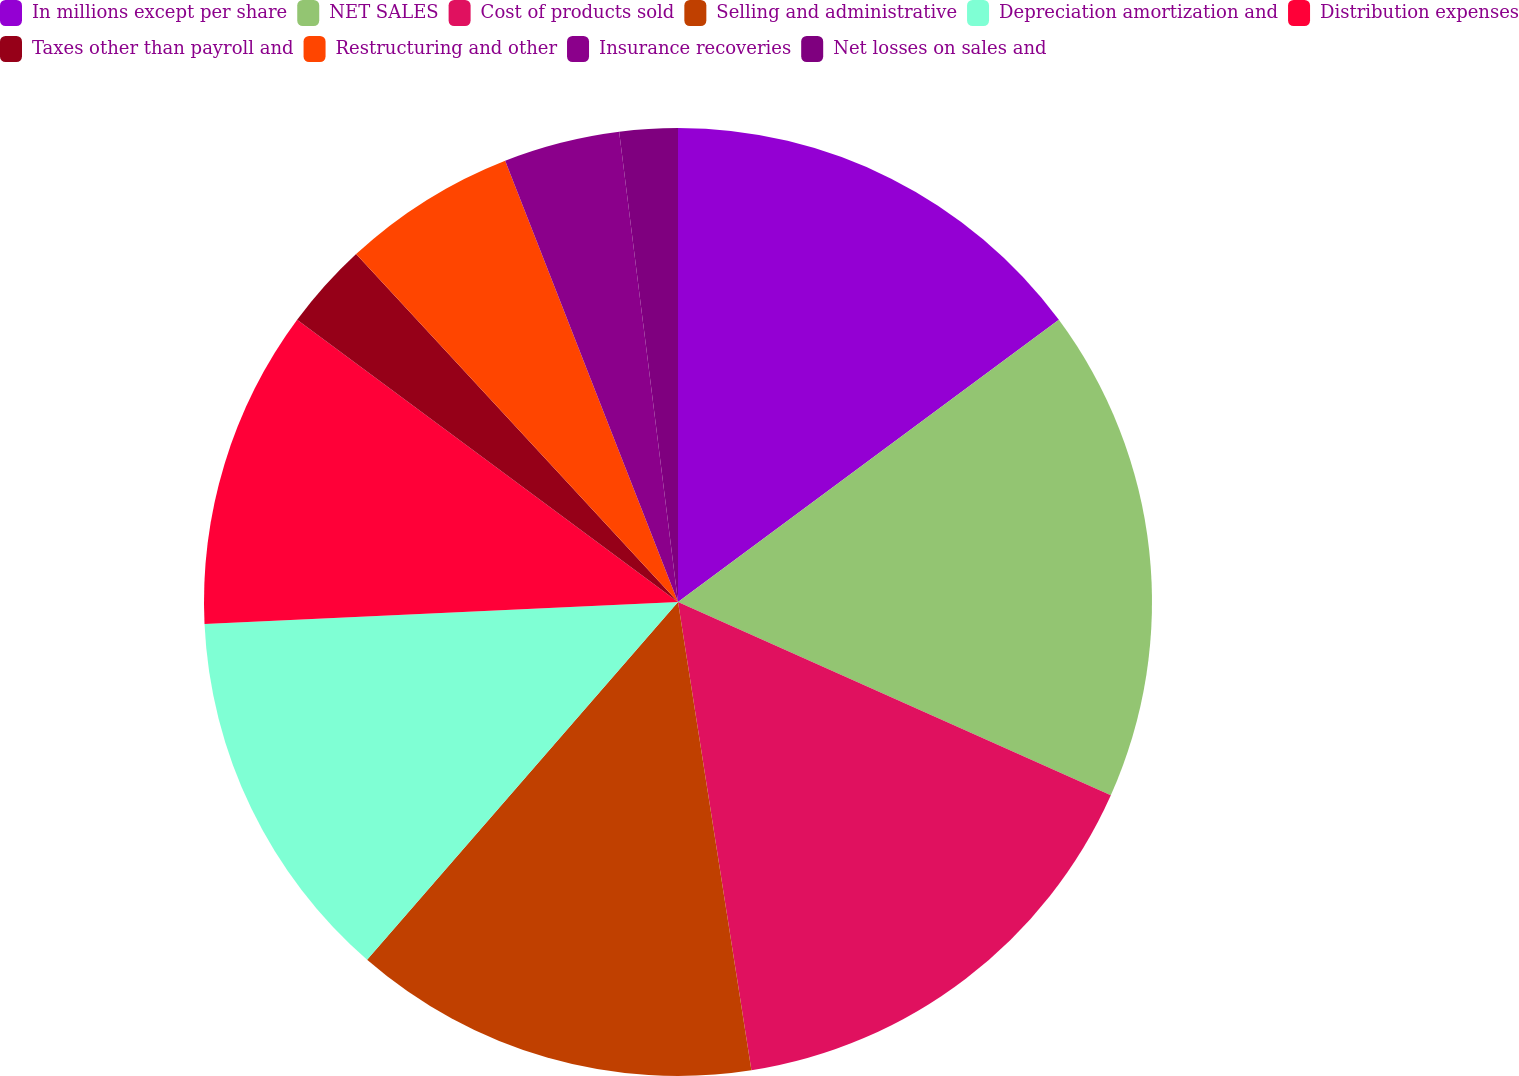Convert chart to OTSL. <chart><loc_0><loc_0><loc_500><loc_500><pie_chart><fcel>In millions except per share<fcel>NET SALES<fcel>Cost of products sold<fcel>Selling and administrative<fcel>Depreciation amortization and<fcel>Distribution expenses<fcel>Taxes other than payroll and<fcel>Restructuring and other<fcel>Insurance recoveries<fcel>Net losses on sales and<nl><fcel>14.85%<fcel>16.83%<fcel>15.84%<fcel>13.86%<fcel>12.87%<fcel>10.89%<fcel>2.97%<fcel>5.94%<fcel>3.96%<fcel>1.98%<nl></chart> 